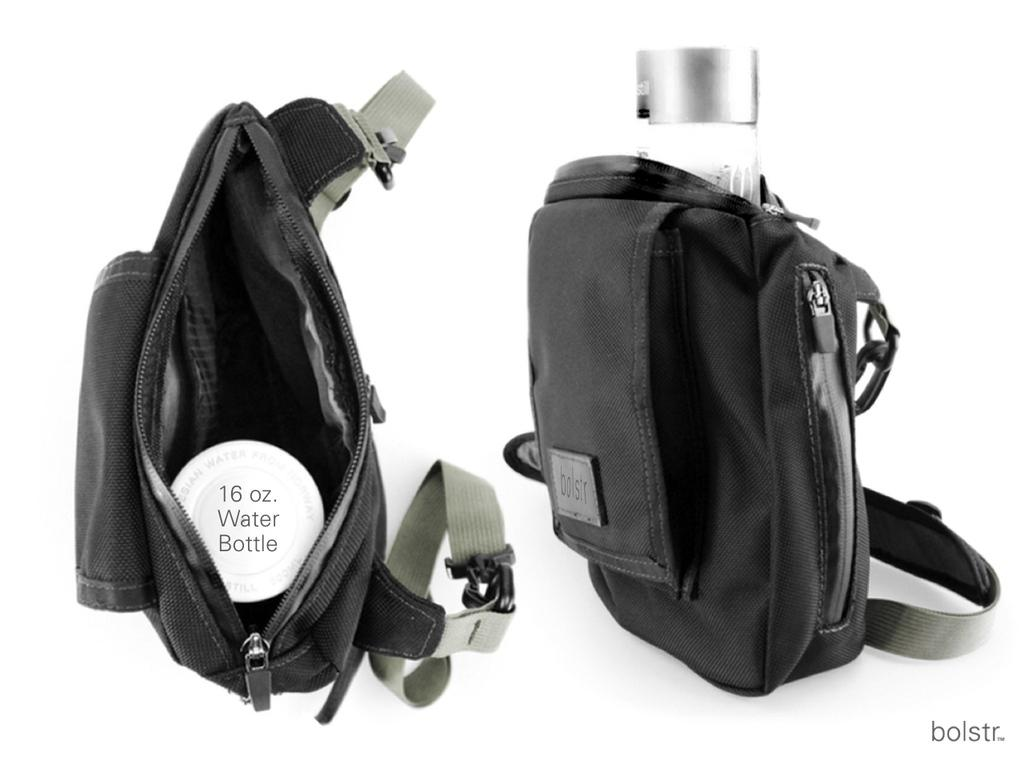How many bags are visible in the image? There are two bags in the image. What are the bags containing? The bags contain water bottles. What type of cough can be heard in the image? There is no sound or indication of a cough in the image. 